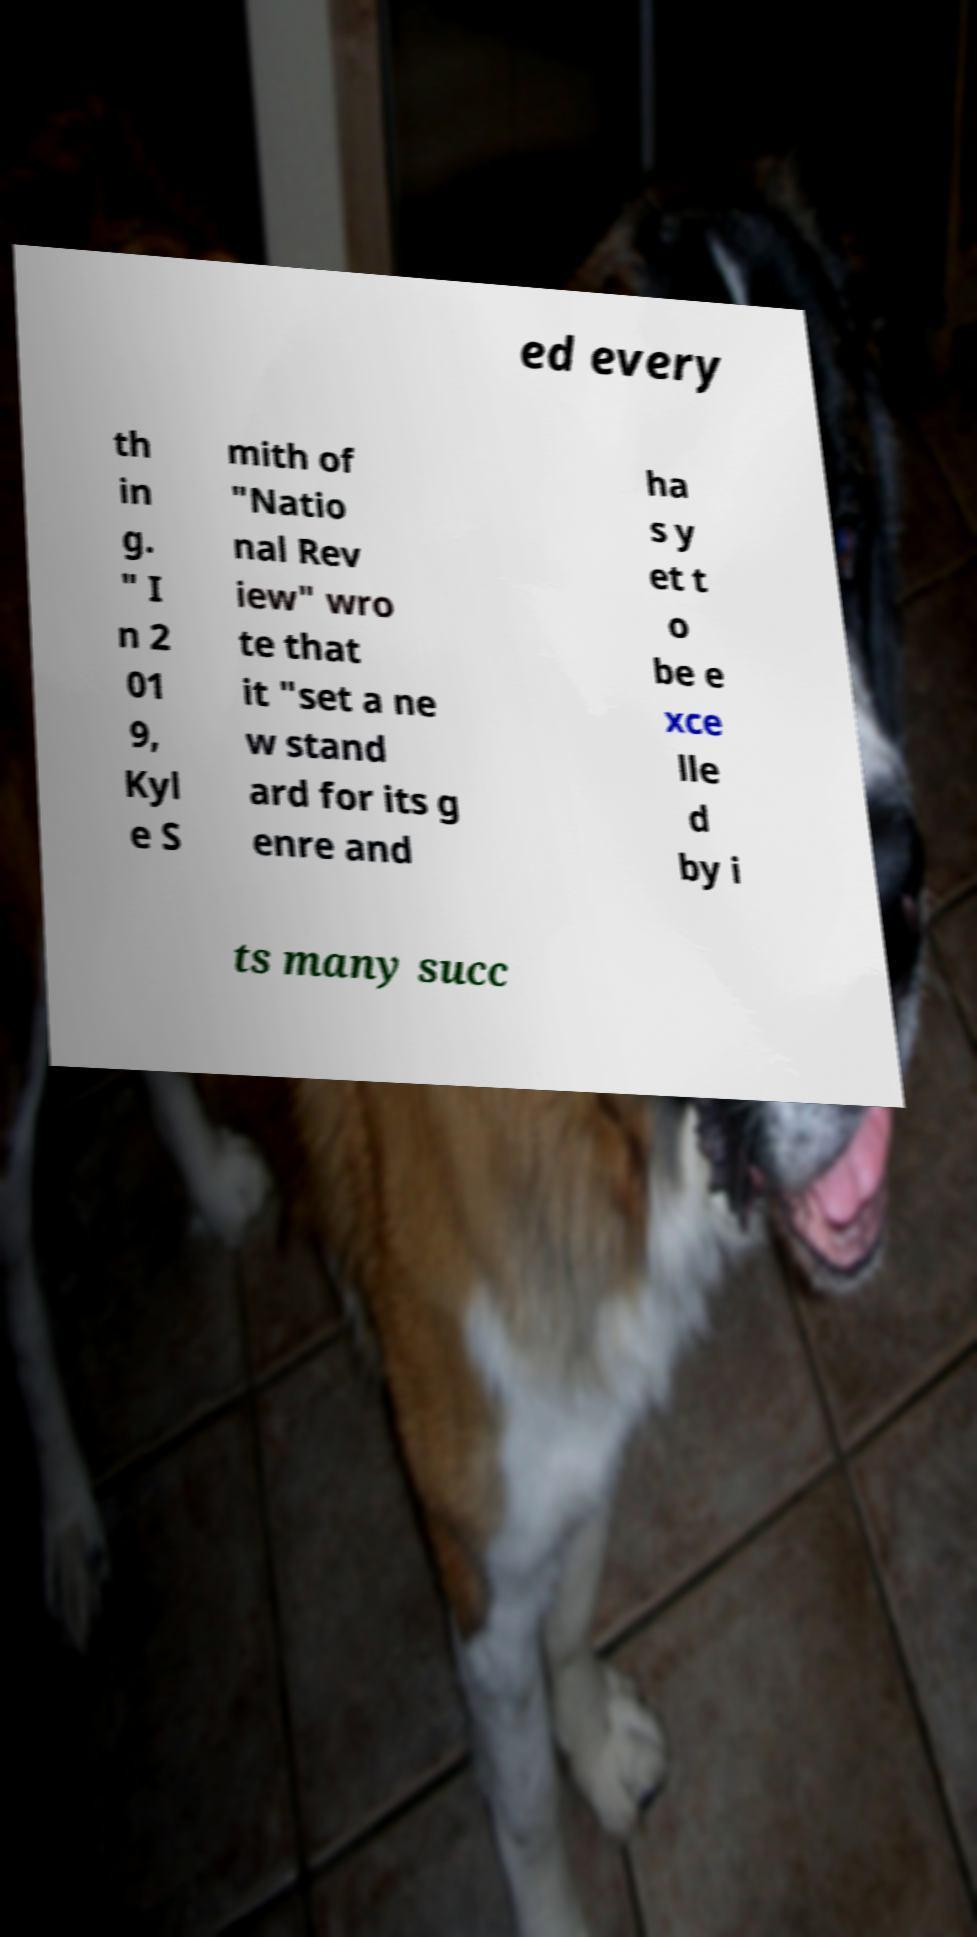For documentation purposes, I need the text within this image transcribed. Could you provide that? ed every th in g. " I n 2 01 9, Kyl e S mith of "Natio nal Rev iew" wro te that it "set a ne w stand ard for its g enre and ha s y et t o be e xce lle d by i ts many succ 